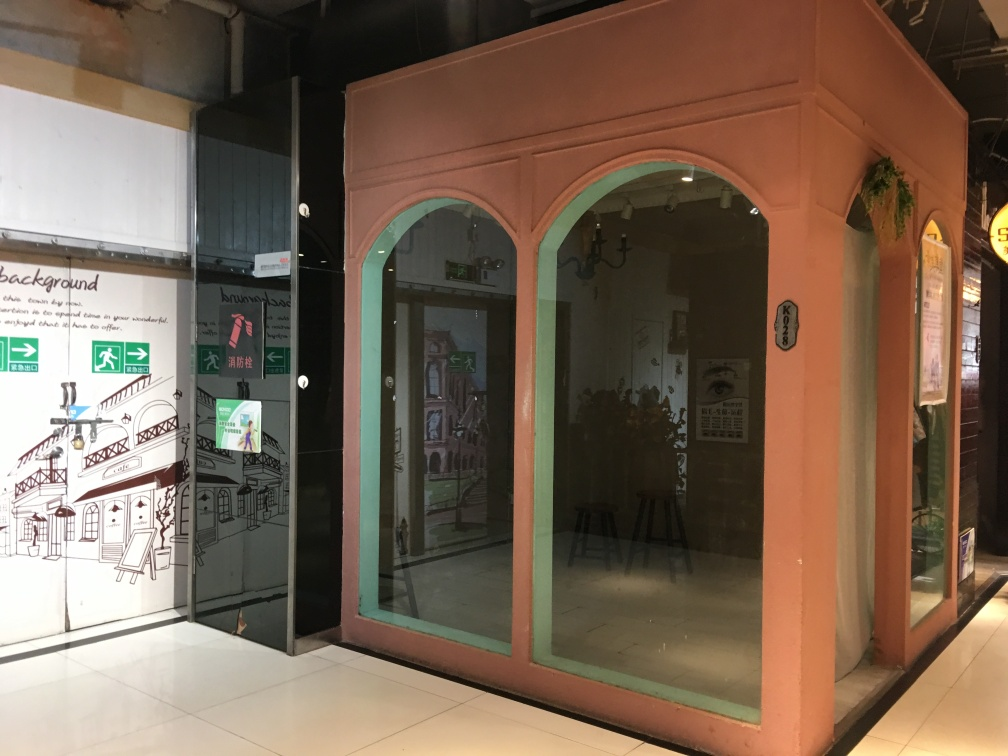What does the sign on the glass door indicate? The sign on the glass door includes an icon of a face with a mask, which typically indicates a health or safety notice, possibly related to guidelines for wearing a face mask indoors. The text beside the sign might give specific instructions or information about health measures in place within the establishment. 